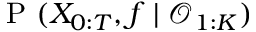<formula> <loc_0><loc_0><loc_500><loc_500>P ( X _ { 0 \colon T } , f | \mathcal { O } _ { 1 \colon K } )</formula> 